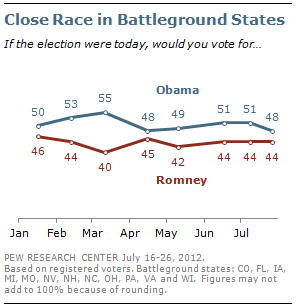Specify some key components in this picture. The line that represents Mitt Romney is red, The largest difference and the smallest difference in opinions between the two candidates is 18. 